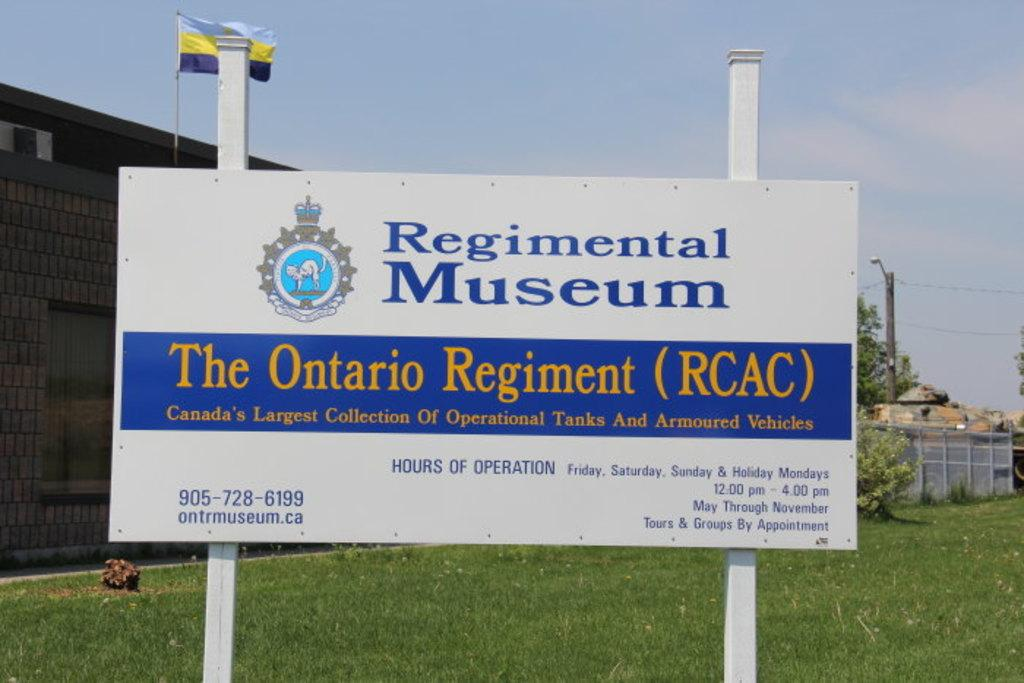Provide a one-sentence caption for the provided image. The image portrays a welcome sign for the Ontario Regiment's Regimental Museum. 